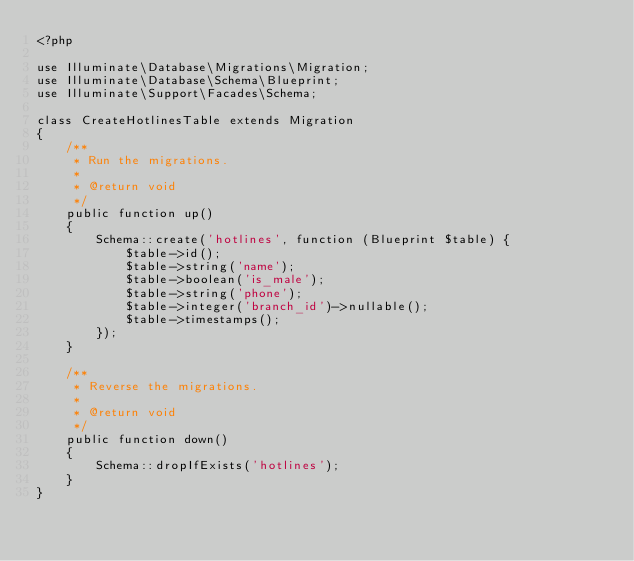Convert code to text. <code><loc_0><loc_0><loc_500><loc_500><_PHP_><?php

use Illuminate\Database\Migrations\Migration;
use Illuminate\Database\Schema\Blueprint;
use Illuminate\Support\Facades\Schema;

class CreateHotlinesTable extends Migration
{
    /**
     * Run the migrations.
     *
     * @return void
     */
    public function up()
    {
        Schema::create('hotlines', function (Blueprint $table) {
            $table->id();
            $table->string('name');
            $table->boolean('is_male');
            $table->string('phone');
            $table->integer('branch_id')->nullable();
            $table->timestamps();
        });
    }

    /**
     * Reverse the migrations.
     *
     * @return void
     */
    public function down()
    {
        Schema::dropIfExists('hotlines');
    }
}
</code> 